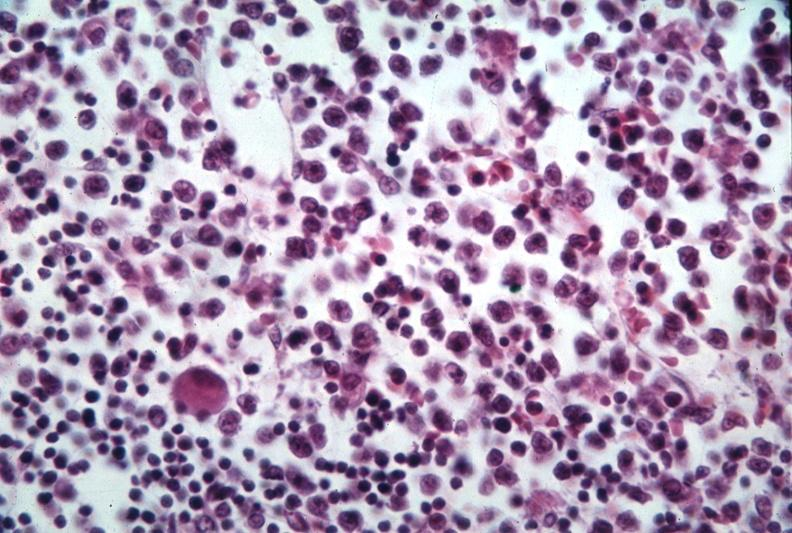s cut present?
Answer the question using a single word or phrase. No 